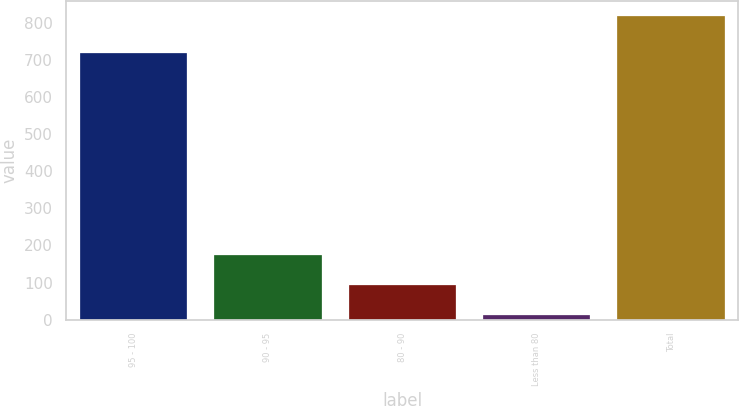Convert chart. <chart><loc_0><loc_0><loc_500><loc_500><bar_chart><fcel>95 - 100<fcel>90 - 95<fcel>80 - 90<fcel>Less than 80<fcel>Total<nl><fcel>719<fcel>173.2<fcel>92.6<fcel>12<fcel>818<nl></chart> 